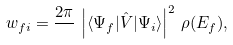<formula> <loc_0><loc_0><loc_500><loc_500>w _ { f i } = \frac { 2 \pi } { } \, \left | \langle \Psi _ { f } | { \hat { V } } | \Psi _ { i } \rangle \right | ^ { 2 } \, \rho ( E _ { f } ) ,</formula> 